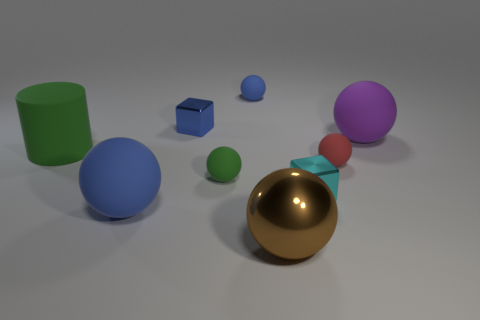What is the shape of the matte thing that is the same color as the big matte cylinder?
Give a very brief answer. Sphere. Are there any balls to the right of the green rubber object that is on the right side of the small shiny block that is on the left side of the big shiny ball?
Keep it short and to the point. Yes. Is the number of blue metal things right of the brown shiny sphere greater than the number of big green metal cubes?
Provide a short and direct response. No. Do the red rubber object right of the green rubber sphere and the large blue matte thing have the same shape?
Offer a very short reply. Yes. Is there any other thing that is the same material as the cyan object?
Offer a terse response. Yes. What number of things are matte spheres or large things that are on the left side of the brown metallic sphere?
Keep it short and to the point. 6. What size is the metallic object that is to the left of the small cyan thing and in front of the large purple matte object?
Ensure brevity in your answer.  Large. Are there more shiny spheres to the left of the tiny blue matte object than large things that are on the right side of the large brown shiny sphere?
Your answer should be compact. No. There is a large metallic thing; is its shape the same as the blue rubber thing in front of the small cyan metallic object?
Offer a terse response. Yes. What number of other things are there of the same shape as the tiny red matte object?
Ensure brevity in your answer.  5. 